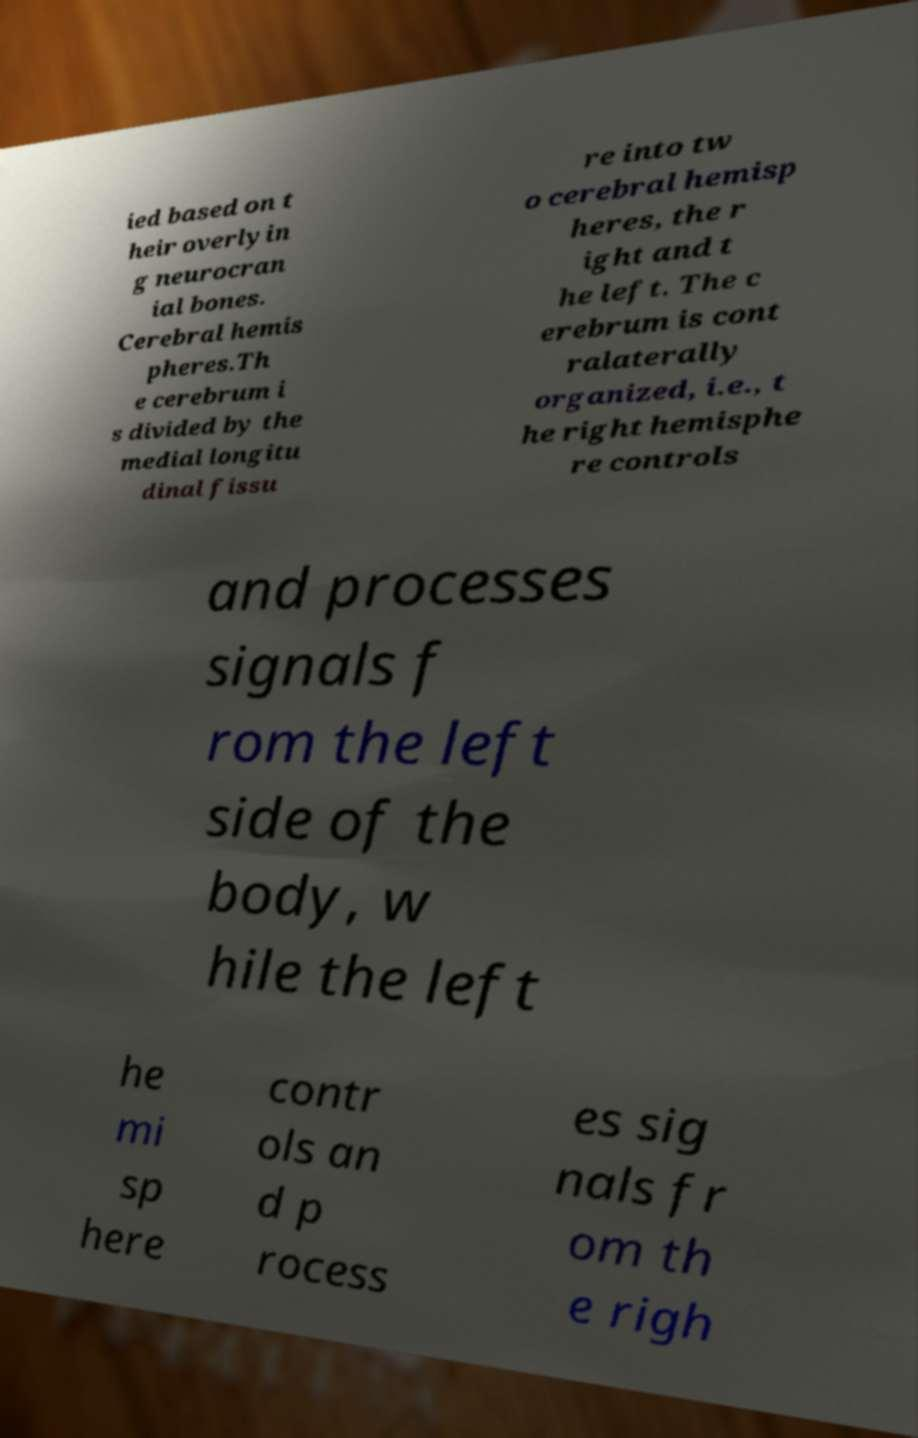Can you accurately transcribe the text from the provided image for me? ied based on t heir overlyin g neurocran ial bones. Cerebral hemis pheres.Th e cerebrum i s divided by the medial longitu dinal fissu re into tw o cerebral hemisp heres, the r ight and t he left. The c erebrum is cont ralaterally organized, i.e., t he right hemisphe re controls and processes signals f rom the left side of the body, w hile the left he mi sp here contr ols an d p rocess es sig nals fr om th e righ 